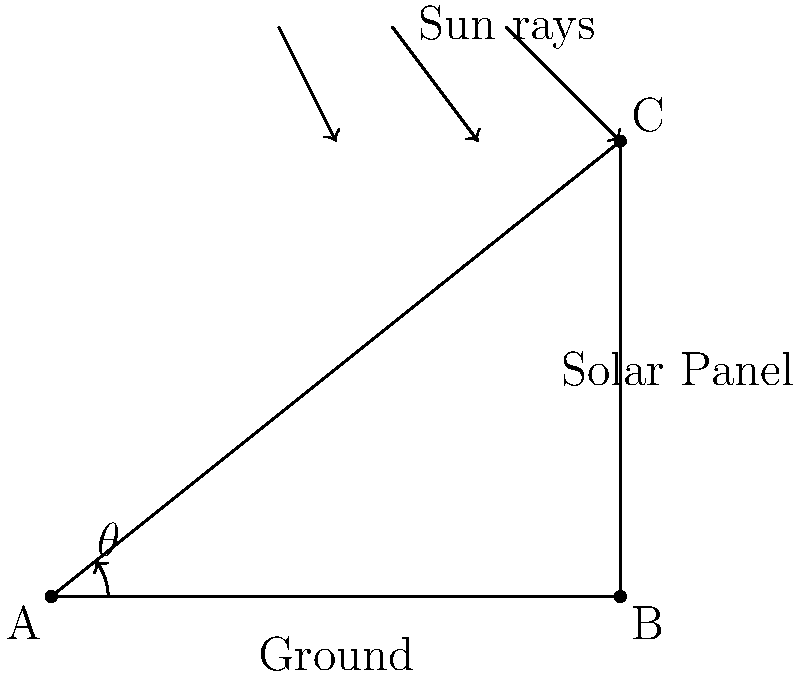A solar panel is installed on a roof as shown in the diagram. If the optimal angle for solar panel placement in your area is 38.7° from the horizontal, what is the length of the support (AC) needed to achieve this angle for a panel that is 100 cm wide (AB)? To solve this problem, we'll use trigonometry:

1) In the right triangle ABC:
   - AB is the base (width of the panel)
   - AC is the hypotenuse (support length)
   - θ is the angle between AB and AC (optimal angle)

2) We know:
   - AB = 100 cm
   - θ = 38.7°

3) We need to find AC. We can use the cosine function:

   $\cos θ = \frac{\text{adjacent}}{\text{hypotenuse}} = \frac{AB}{AC}$

4) Rearranging the equation:

   $AC = \frac{AB}{\cos θ}$

5) Plugging in the values:

   $AC = \frac{100}{\cos 38.7°}$

6) Using a calculator:

   $AC ≈ 127.1$ cm

Therefore, the support (AC) needs to be approximately 127.1 cm long to achieve the optimal angle of 38.7°.
Answer: 127.1 cm 